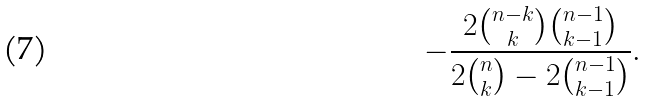Convert formula to latex. <formula><loc_0><loc_0><loc_500><loc_500>- \frac { 2 \binom { n - k } { k } \binom { n - 1 } { k - 1 } } { 2 \binom { n } { k } - 2 \binom { n - 1 } { k - 1 } } .</formula> 